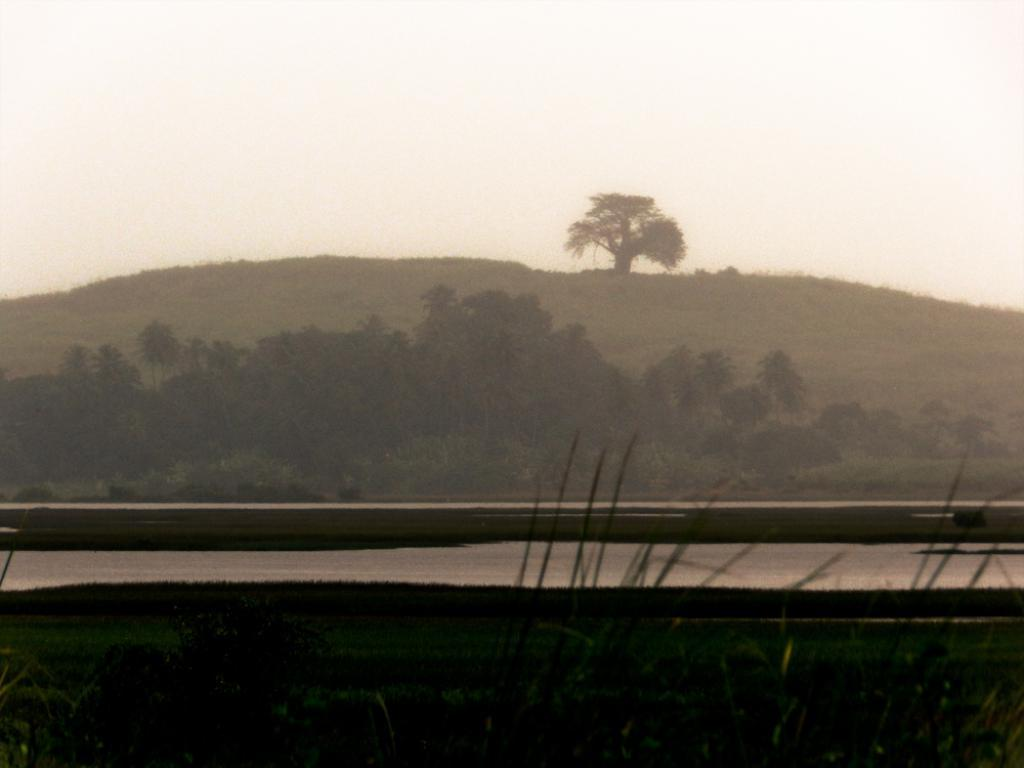What is located at the bottom of the image? There is a road at the bottom side of the image. What can be seen in the background of the image? There are trees in the background area of the image. How many cents are visible on the road in the image? There are no cents visible on the road in the image. Can you see any bones in the image? There are no bones present in the image. 